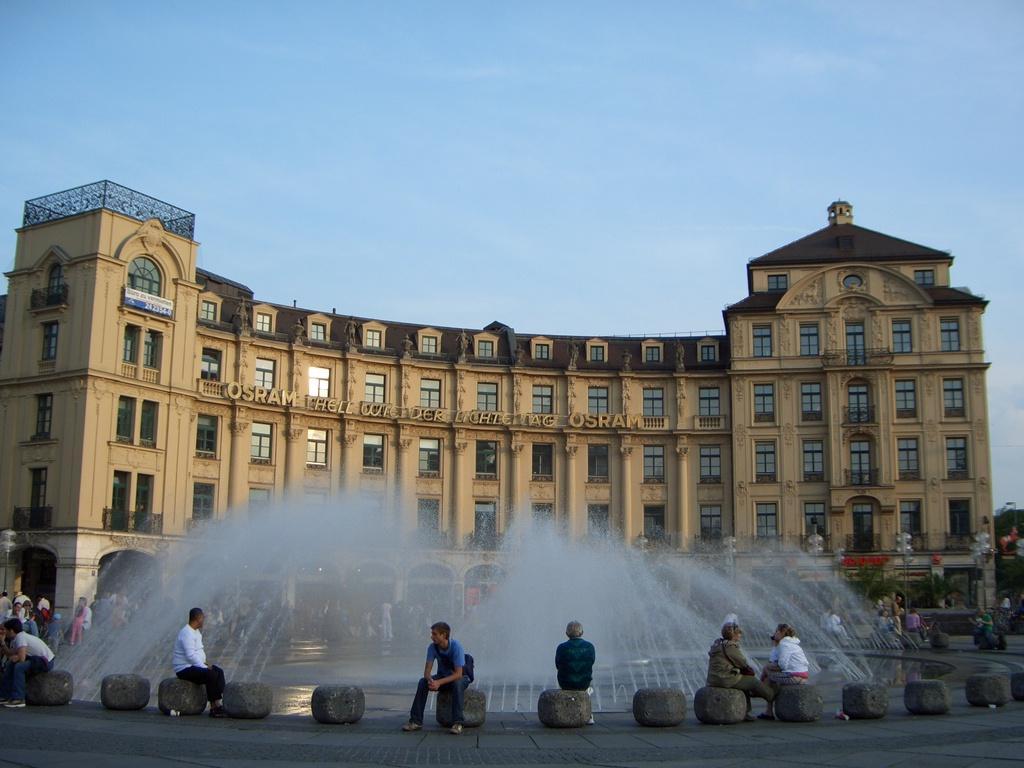Can you describe this image briefly? At the bottom of this image, there are rocks arranged. On some of these rocks, there are persons, sitting. In the background, there is a waterfall, there are persons, there is a building which is having windows, there are trees and there are clouds in the sky. 